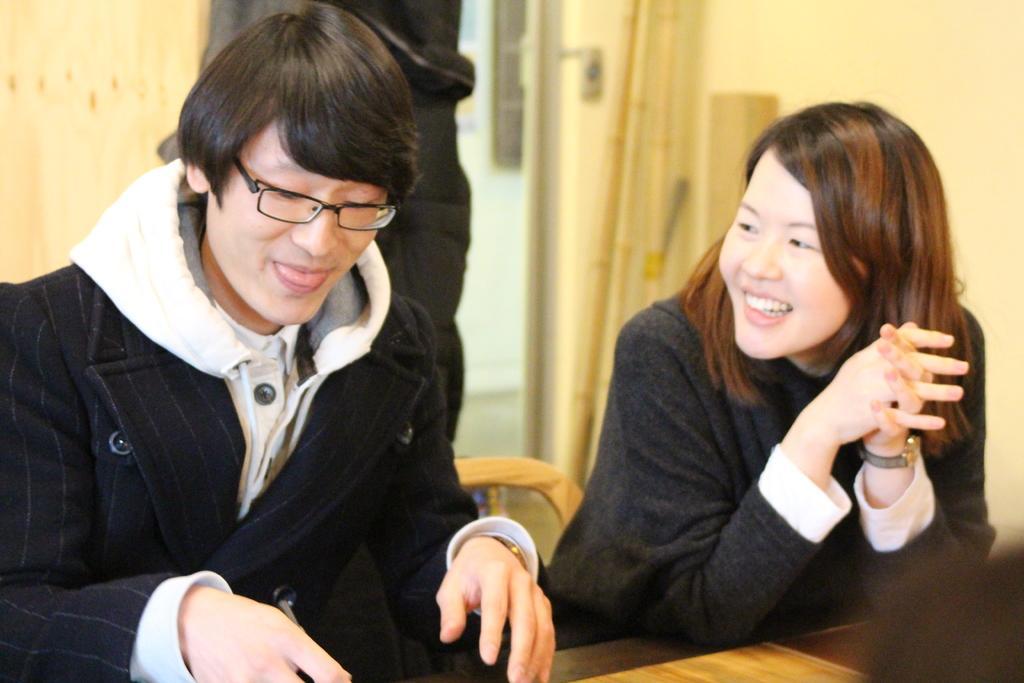In one or two sentences, can you explain what this image depicts? In this image we can see a man and a woman. They are smiling. Here we can see a table and an object. In the background we can see wall and other objects. 